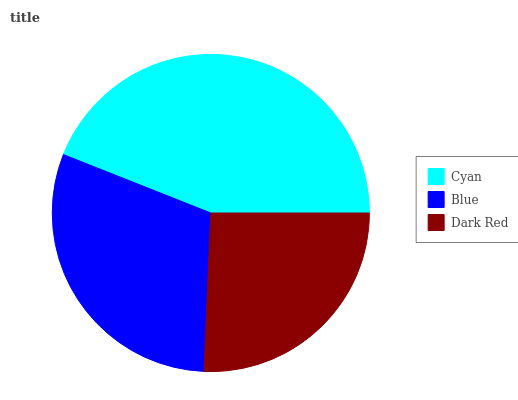Is Dark Red the minimum?
Answer yes or no. Yes. Is Cyan the maximum?
Answer yes or no. Yes. Is Blue the minimum?
Answer yes or no. No. Is Blue the maximum?
Answer yes or no. No. Is Cyan greater than Blue?
Answer yes or no. Yes. Is Blue less than Cyan?
Answer yes or no. Yes. Is Blue greater than Cyan?
Answer yes or no. No. Is Cyan less than Blue?
Answer yes or no. No. Is Blue the high median?
Answer yes or no. Yes. Is Blue the low median?
Answer yes or no. Yes. Is Cyan the high median?
Answer yes or no. No. Is Cyan the low median?
Answer yes or no. No. 